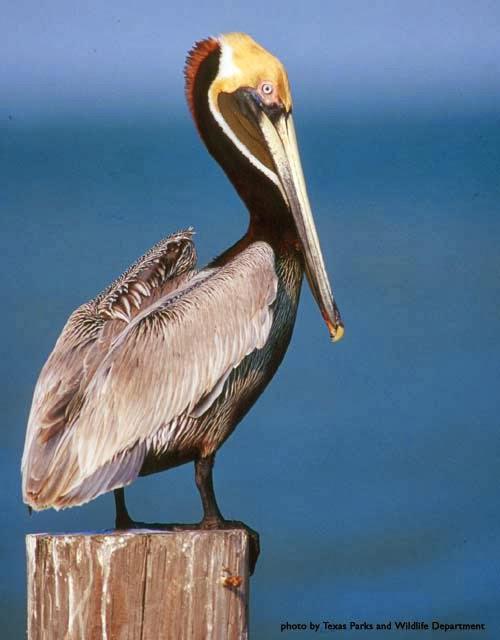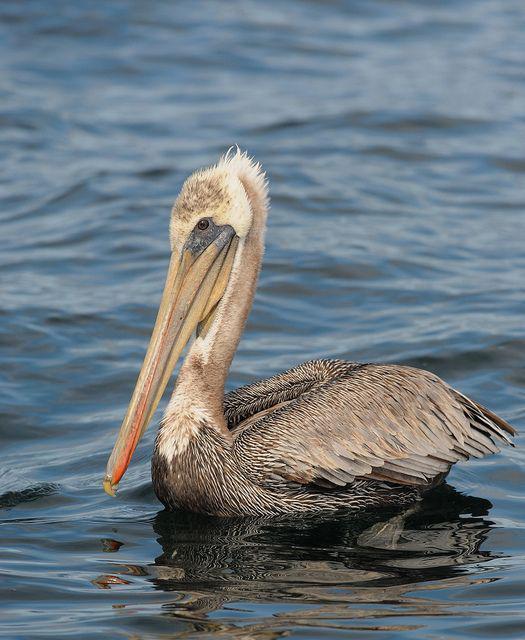The first image is the image on the left, the second image is the image on the right. Analyze the images presented: Is the assertion "The bird in the right image is facing towards the left." valid? Answer yes or no. Yes. The first image is the image on the left, the second image is the image on the right. For the images displayed, is the sentence "A single bird is flying over the water in the image on the left." factually correct? Answer yes or no. No. 